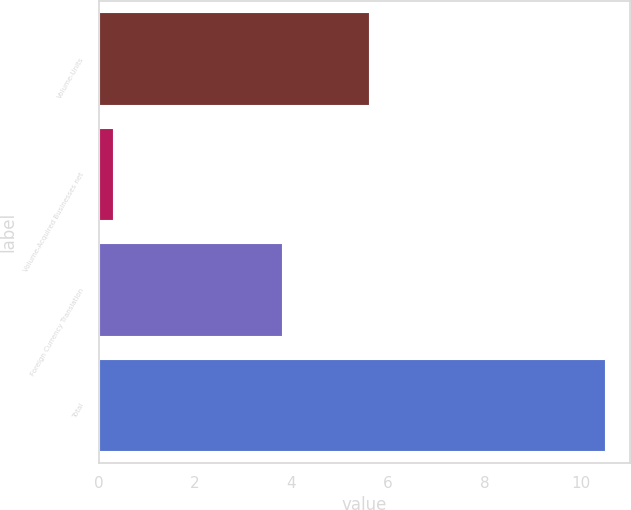Convert chart to OTSL. <chart><loc_0><loc_0><loc_500><loc_500><bar_chart><fcel>Volume-Units<fcel>Volume-Acquired Businesses net<fcel>Foreign Currency Translation<fcel>Total<nl><fcel>5.6<fcel>0.3<fcel>3.8<fcel>10.5<nl></chart> 